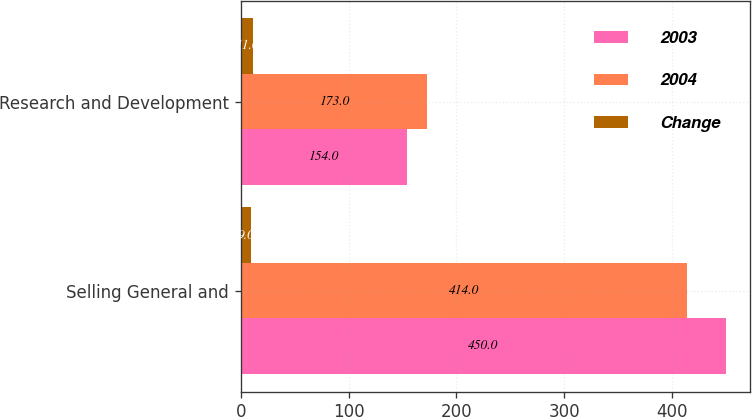Convert chart to OTSL. <chart><loc_0><loc_0><loc_500><loc_500><stacked_bar_chart><ecel><fcel>Selling General and<fcel>Research and Development<nl><fcel>2003<fcel>450<fcel>154<nl><fcel>2004<fcel>414<fcel>173<nl><fcel>Change<fcel>9<fcel>11<nl></chart> 